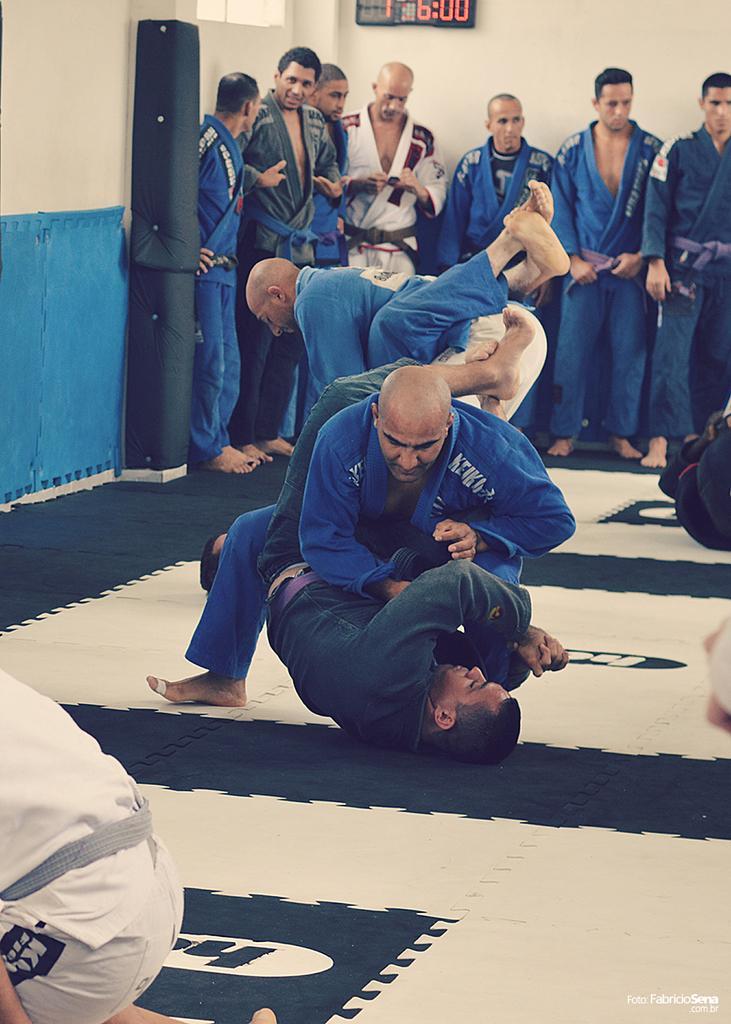Describe this image in one or two sentences. Here we can see two pairs of men fighting on the floor. In the background there are few men standing on the floor,wall and an electronic device on the wall. On the left at the bottom corner we can see a person in squat position on the floor. 